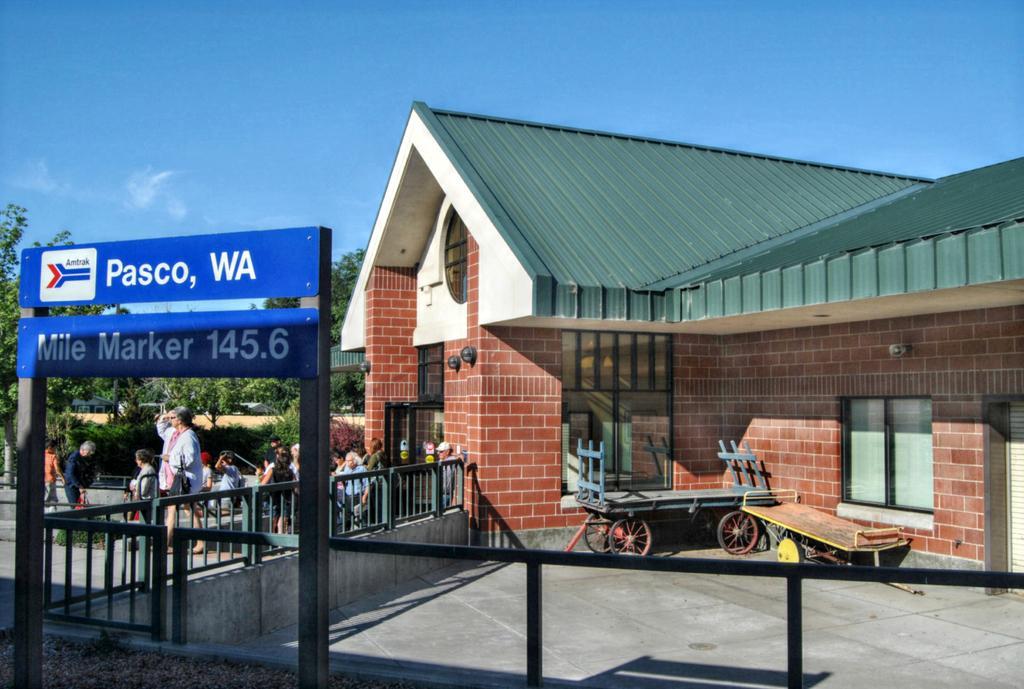Could you give a brief overview of what you see in this image? In this image there is the sky truncated towards the top of the image, there are trees truncated towards the left of the image, there is a house truncated towards the right of the image, there are objects on the ground, there is a fencing, there are group of persons, there are boards, there is text on the boards, there is a fencing towards the bottom of the image, there are windows. 